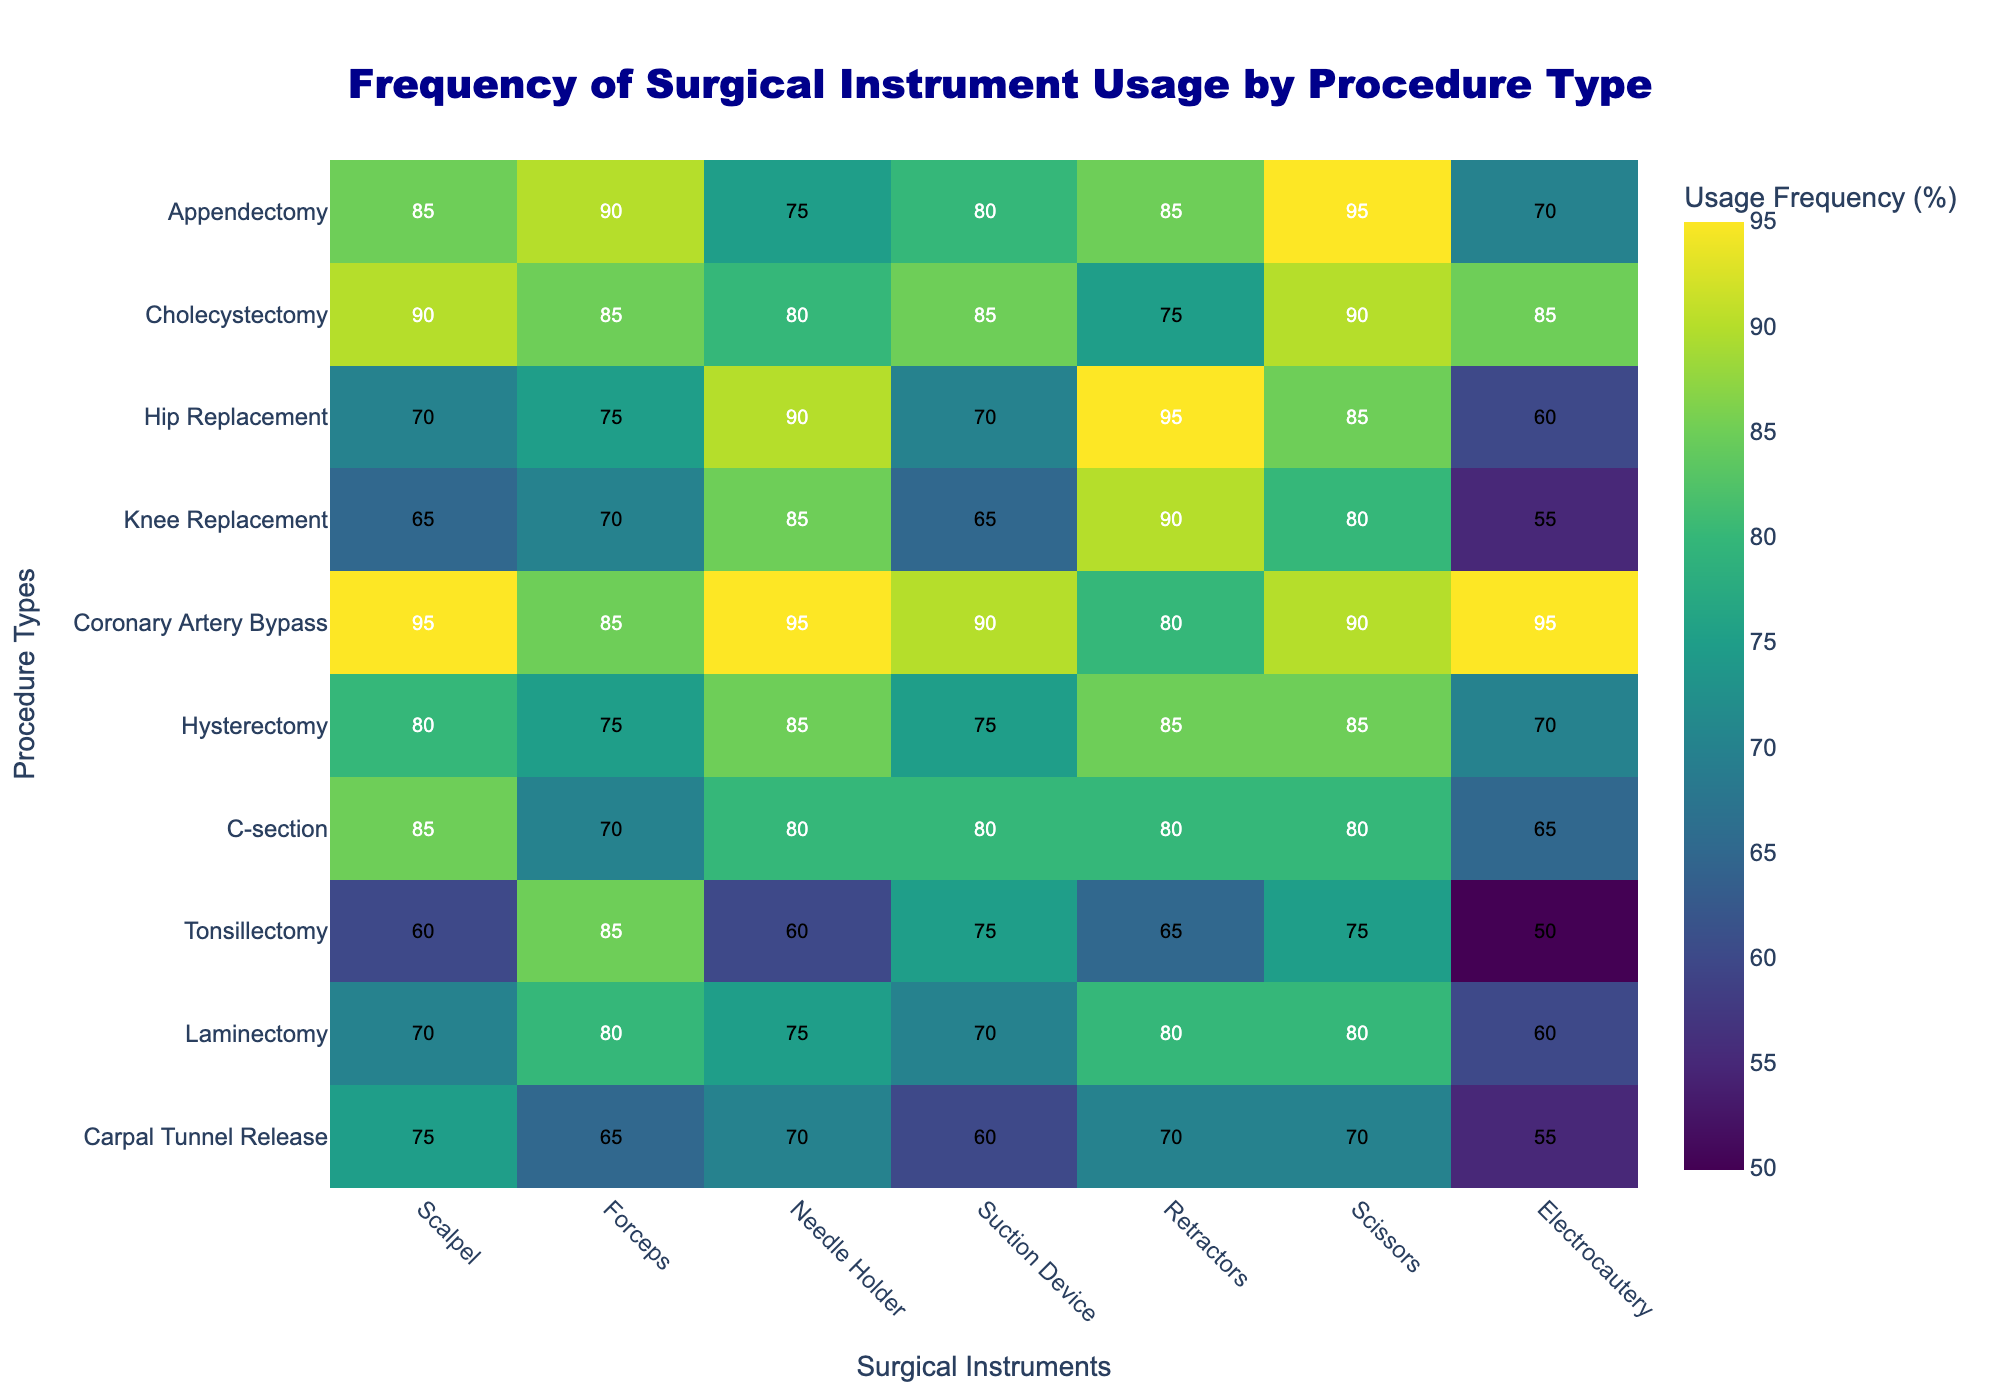How is the axis labeled for procedure types? The axis on the left of the heatmap shows the different types of procedures. Each row corresponds to a different procedure type.
Answer: Procedure Types What is the title of the heatmap? The title is shown at the top of the heatmap and indicates what the figure represents.
Answer: Frequency of Surgical Instrument Usage by Procedure Type Which instrument has the highest usage frequency in Hysterectomy? Locate the row for Hysterectomy, then find the highest value within that row.
Answer: Scissors (85%) Which procedure shows the least usage of Electrocautery? Look across the Electrocautery column to find the lowest value and identify the corresponding procedure type.
Answer: Tonsillectomy (50%) How many procedure types have a usage frequency above 80% for Scalpel? Check the Scalpel column and count the number of procedure types with values greater than 80.
Answer: 5 What is the average usage frequency of Needle Holders across all procedures? Add all the values in the Needle Holder column and divide by the number of procedure types. (75 + 80 + 90 + 85 + 95 + 85 + 80 + 60 + 75 + 70) / 10 = 79.5
Answer: 79.5% Compare the frequency of Suction Device usage between Appendectomy and Cholecystectomy. Look at the Suction Device column and find the values for both Appendectomy and Cholecystectomy. Appendectomy: 80, Cholecystectomy: 85
Answer: Cholecystectomy has higher usage Which procedure type has the most consistent high usage of all instruments? Identify the procedure with the least fluctuation and highest values in its row.
Answer: Coronary Artery Bypass Find the median usage value for the Retractors across all procedures. Arrange the Retractors values in ascending order and find the median. (65, 70, 75, 75, 80, 80, 80, 85, 90, 95) The median is the average of the 5th and 6th elements.
Answer: 80 Which instrument has the highest usage frequency variation across different procedures? Compare the range of frequencies (highest minus lowest value) for each instrument column.
Answer: Electrocautery (range = 95 - 50 = 45) 